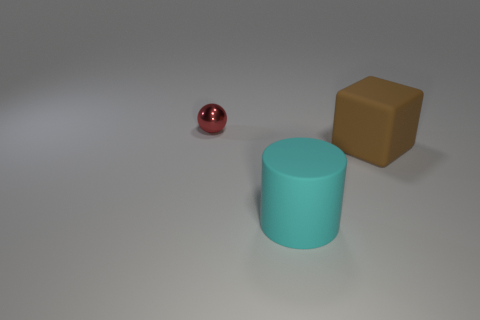Add 2 brown rubber blocks. How many objects exist? 5 Subtract all spheres. How many objects are left? 2 Add 3 small red objects. How many small red objects are left? 4 Add 2 green objects. How many green objects exist? 2 Subtract 0 cyan blocks. How many objects are left? 3 Subtract all brown matte objects. Subtract all big yellow metallic balls. How many objects are left? 2 